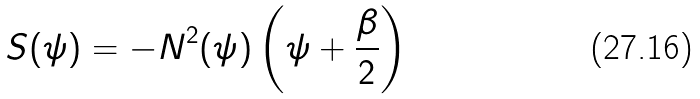<formula> <loc_0><loc_0><loc_500><loc_500>S ( \psi ) = - N ^ { 2 } ( \psi ) \left ( \psi + \frac { \beta } { 2 } \right )</formula> 